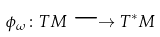Convert formula to latex. <formula><loc_0><loc_0><loc_500><loc_500>\phi _ { \omega } \colon T M \longrightarrow T ^ { * } M</formula> 